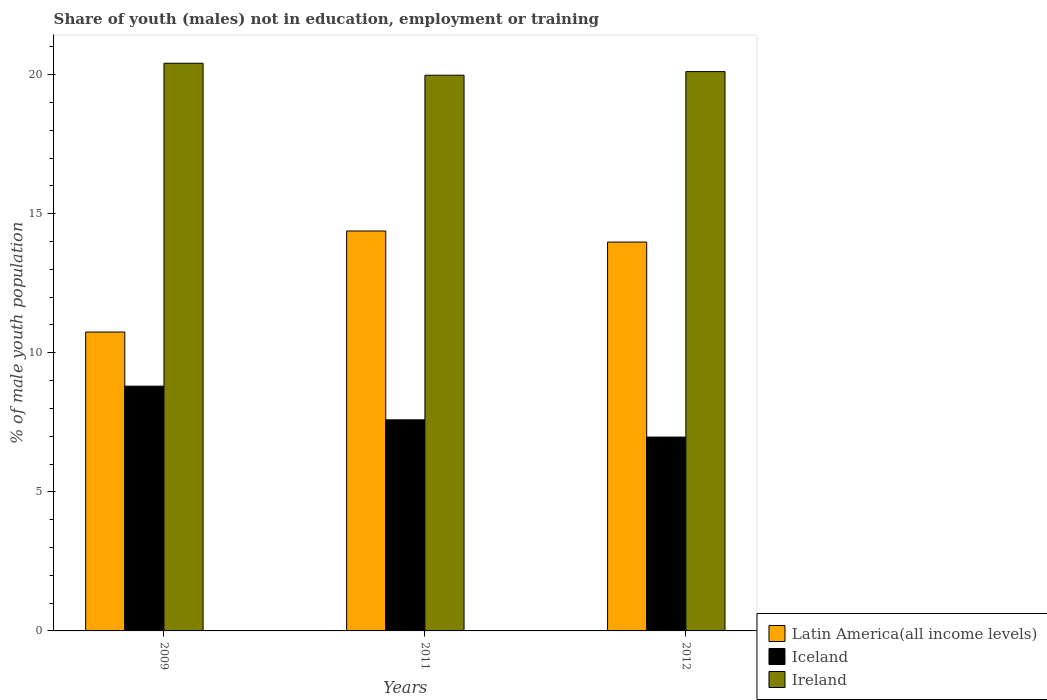How many different coloured bars are there?
Make the answer very short. 3. Are the number of bars per tick equal to the number of legend labels?
Your answer should be very brief. Yes. Are the number of bars on each tick of the X-axis equal?
Provide a short and direct response. Yes. What is the percentage of unemployed males population in in Latin America(all income levels) in 2009?
Provide a succinct answer. 10.75. Across all years, what is the maximum percentage of unemployed males population in in Latin America(all income levels)?
Ensure brevity in your answer.  14.38. Across all years, what is the minimum percentage of unemployed males population in in Iceland?
Offer a very short reply. 6.97. What is the total percentage of unemployed males population in in Ireland in the graph?
Ensure brevity in your answer.  60.5. What is the difference between the percentage of unemployed males population in in Latin America(all income levels) in 2011 and that in 2012?
Give a very brief answer. 0.4. What is the difference between the percentage of unemployed males population in in Iceland in 2009 and the percentage of unemployed males population in in Ireland in 2012?
Your answer should be very brief. -11.31. What is the average percentage of unemployed males population in in Latin America(all income levels) per year?
Offer a very short reply. 13.04. In the year 2012, what is the difference between the percentage of unemployed males population in in Latin America(all income levels) and percentage of unemployed males population in in Ireland?
Offer a very short reply. -6.13. What is the ratio of the percentage of unemployed males population in in Latin America(all income levels) in 2009 to that in 2011?
Your response must be concise. 0.75. Is the percentage of unemployed males population in in Iceland in 2011 less than that in 2012?
Provide a short and direct response. No. Is the difference between the percentage of unemployed males population in in Latin America(all income levels) in 2009 and 2011 greater than the difference between the percentage of unemployed males population in in Ireland in 2009 and 2011?
Ensure brevity in your answer.  No. What is the difference between the highest and the second highest percentage of unemployed males population in in Latin America(all income levels)?
Offer a terse response. 0.4. What is the difference between the highest and the lowest percentage of unemployed males population in in Latin America(all income levels)?
Give a very brief answer. 3.63. Is the sum of the percentage of unemployed males population in in Latin America(all income levels) in 2009 and 2012 greater than the maximum percentage of unemployed males population in in Ireland across all years?
Your answer should be very brief. Yes. What does the 1st bar from the left in 2011 represents?
Offer a terse response. Latin America(all income levels). Is it the case that in every year, the sum of the percentage of unemployed males population in in Latin America(all income levels) and percentage of unemployed males population in in Iceland is greater than the percentage of unemployed males population in in Ireland?
Offer a very short reply. No. How many bars are there?
Make the answer very short. 9. Are all the bars in the graph horizontal?
Your answer should be very brief. No. Are the values on the major ticks of Y-axis written in scientific E-notation?
Provide a succinct answer. No. Does the graph contain any zero values?
Your answer should be compact. No. Where does the legend appear in the graph?
Keep it short and to the point. Bottom right. How many legend labels are there?
Offer a very short reply. 3. What is the title of the graph?
Your answer should be very brief. Share of youth (males) not in education, employment or training. What is the label or title of the X-axis?
Your answer should be compact. Years. What is the label or title of the Y-axis?
Your response must be concise. % of male youth population. What is the % of male youth population of Latin America(all income levels) in 2009?
Offer a terse response. 10.75. What is the % of male youth population of Iceland in 2009?
Offer a terse response. 8.8. What is the % of male youth population in Ireland in 2009?
Make the answer very short. 20.41. What is the % of male youth population of Latin America(all income levels) in 2011?
Provide a short and direct response. 14.38. What is the % of male youth population of Iceland in 2011?
Your response must be concise. 7.59. What is the % of male youth population in Ireland in 2011?
Your response must be concise. 19.98. What is the % of male youth population in Latin America(all income levels) in 2012?
Offer a very short reply. 13.98. What is the % of male youth population in Iceland in 2012?
Make the answer very short. 6.97. What is the % of male youth population of Ireland in 2012?
Provide a succinct answer. 20.11. Across all years, what is the maximum % of male youth population in Latin America(all income levels)?
Your answer should be very brief. 14.38. Across all years, what is the maximum % of male youth population of Iceland?
Keep it short and to the point. 8.8. Across all years, what is the maximum % of male youth population in Ireland?
Offer a very short reply. 20.41. Across all years, what is the minimum % of male youth population of Latin America(all income levels)?
Your response must be concise. 10.75. Across all years, what is the minimum % of male youth population in Iceland?
Give a very brief answer. 6.97. Across all years, what is the minimum % of male youth population of Ireland?
Ensure brevity in your answer.  19.98. What is the total % of male youth population of Latin America(all income levels) in the graph?
Offer a terse response. 39.11. What is the total % of male youth population in Iceland in the graph?
Offer a terse response. 23.36. What is the total % of male youth population of Ireland in the graph?
Your answer should be very brief. 60.5. What is the difference between the % of male youth population of Latin America(all income levels) in 2009 and that in 2011?
Your response must be concise. -3.63. What is the difference between the % of male youth population in Iceland in 2009 and that in 2011?
Ensure brevity in your answer.  1.21. What is the difference between the % of male youth population of Ireland in 2009 and that in 2011?
Make the answer very short. 0.43. What is the difference between the % of male youth population in Latin America(all income levels) in 2009 and that in 2012?
Keep it short and to the point. -3.24. What is the difference between the % of male youth population of Iceland in 2009 and that in 2012?
Your answer should be compact. 1.83. What is the difference between the % of male youth population of Ireland in 2009 and that in 2012?
Your response must be concise. 0.3. What is the difference between the % of male youth population of Latin America(all income levels) in 2011 and that in 2012?
Make the answer very short. 0.4. What is the difference between the % of male youth population of Iceland in 2011 and that in 2012?
Ensure brevity in your answer.  0.62. What is the difference between the % of male youth population of Ireland in 2011 and that in 2012?
Ensure brevity in your answer.  -0.13. What is the difference between the % of male youth population in Latin America(all income levels) in 2009 and the % of male youth population in Iceland in 2011?
Offer a very short reply. 3.16. What is the difference between the % of male youth population in Latin America(all income levels) in 2009 and the % of male youth population in Ireland in 2011?
Ensure brevity in your answer.  -9.23. What is the difference between the % of male youth population in Iceland in 2009 and the % of male youth population in Ireland in 2011?
Give a very brief answer. -11.18. What is the difference between the % of male youth population in Latin America(all income levels) in 2009 and the % of male youth population in Iceland in 2012?
Your response must be concise. 3.78. What is the difference between the % of male youth population of Latin America(all income levels) in 2009 and the % of male youth population of Ireland in 2012?
Your response must be concise. -9.36. What is the difference between the % of male youth population of Iceland in 2009 and the % of male youth population of Ireland in 2012?
Your response must be concise. -11.31. What is the difference between the % of male youth population in Latin America(all income levels) in 2011 and the % of male youth population in Iceland in 2012?
Your response must be concise. 7.41. What is the difference between the % of male youth population of Latin America(all income levels) in 2011 and the % of male youth population of Ireland in 2012?
Your answer should be compact. -5.73. What is the difference between the % of male youth population in Iceland in 2011 and the % of male youth population in Ireland in 2012?
Keep it short and to the point. -12.52. What is the average % of male youth population in Latin America(all income levels) per year?
Your answer should be very brief. 13.04. What is the average % of male youth population in Iceland per year?
Make the answer very short. 7.79. What is the average % of male youth population of Ireland per year?
Provide a succinct answer. 20.17. In the year 2009, what is the difference between the % of male youth population in Latin America(all income levels) and % of male youth population in Iceland?
Keep it short and to the point. 1.95. In the year 2009, what is the difference between the % of male youth population of Latin America(all income levels) and % of male youth population of Ireland?
Your answer should be very brief. -9.66. In the year 2009, what is the difference between the % of male youth population in Iceland and % of male youth population in Ireland?
Offer a very short reply. -11.61. In the year 2011, what is the difference between the % of male youth population in Latin America(all income levels) and % of male youth population in Iceland?
Your answer should be very brief. 6.79. In the year 2011, what is the difference between the % of male youth population of Latin America(all income levels) and % of male youth population of Ireland?
Offer a terse response. -5.6. In the year 2011, what is the difference between the % of male youth population of Iceland and % of male youth population of Ireland?
Give a very brief answer. -12.39. In the year 2012, what is the difference between the % of male youth population of Latin America(all income levels) and % of male youth population of Iceland?
Ensure brevity in your answer.  7.01. In the year 2012, what is the difference between the % of male youth population of Latin America(all income levels) and % of male youth population of Ireland?
Your answer should be very brief. -6.13. In the year 2012, what is the difference between the % of male youth population in Iceland and % of male youth population in Ireland?
Offer a very short reply. -13.14. What is the ratio of the % of male youth population of Latin America(all income levels) in 2009 to that in 2011?
Give a very brief answer. 0.75. What is the ratio of the % of male youth population of Iceland in 2009 to that in 2011?
Make the answer very short. 1.16. What is the ratio of the % of male youth population of Ireland in 2009 to that in 2011?
Provide a short and direct response. 1.02. What is the ratio of the % of male youth population of Latin America(all income levels) in 2009 to that in 2012?
Make the answer very short. 0.77. What is the ratio of the % of male youth population in Iceland in 2009 to that in 2012?
Your answer should be very brief. 1.26. What is the ratio of the % of male youth population in Ireland in 2009 to that in 2012?
Your response must be concise. 1.01. What is the ratio of the % of male youth population of Latin America(all income levels) in 2011 to that in 2012?
Your answer should be very brief. 1.03. What is the ratio of the % of male youth population of Iceland in 2011 to that in 2012?
Provide a short and direct response. 1.09. What is the ratio of the % of male youth population in Ireland in 2011 to that in 2012?
Ensure brevity in your answer.  0.99. What is the difference between the highest and the second highest % of male youth population of Latin America(all income levels)?
Provide a succinct answer. 0.4. What is the difference between the highest and the second highest % of male youth population of Iceland?
Provide a short and direct response. 1.21. What is the difference between the highest and the lowest % of male youth population in Latin America(all income levels)?
Give a very brief answer. 3.63. What is the difference between the highest and the lowest % of male youth population of Iceland?
Provide a succinct answer. 1.83. What is the difference between the highest and the lowest % of male youth population in Ireland?
Give a very brief answer. 0.43. 